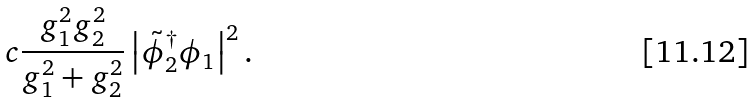<formula> <loc_0><loc_0><loc_500><loc_500>c { \frac { g _ { 1 } ^ { 2 } g _ { 2 } ^ { 2 } } { g _ { 1 } ^ { 2 } + g _ { 2 } ^ { 2 } } } \left | { \tilde { \phi } _ { 2 } } ^ { \dagger } \phi _ { 1 } \right | ^ { 2 } .</formula> 